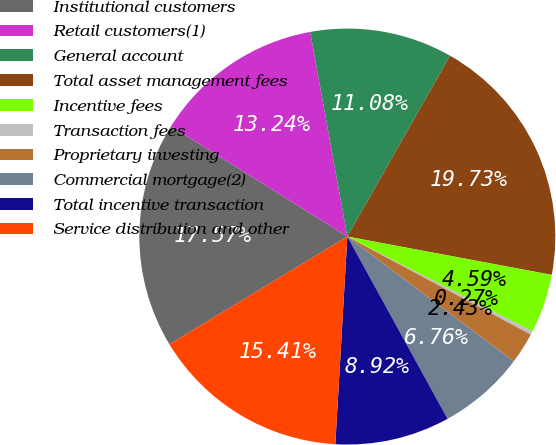Convert chart to OTSL. <chart><loc_0><loc_0><loc_500><loc_500><pie_chart><fcel>Institutional customers<fcel>Retail customers(1)<fcel>General account<fcel>Total asset management fees<fcel>Incentive fees<fcel>Transaction fees<fcel>Proprietary investing<fcel>Commercial mortgage(2)<fcel>Total incentive transaction<fcel>Service distribution and other<nl><fcel>17.57%<fcel>13.24%<fcel>11.08%<fcel>19.73%<fcel>4.59%<fcel>0.27%<fcel>2.43%<fcel>6.76%<fcel>8.92%<fcel>15.41%<nl></chart> 